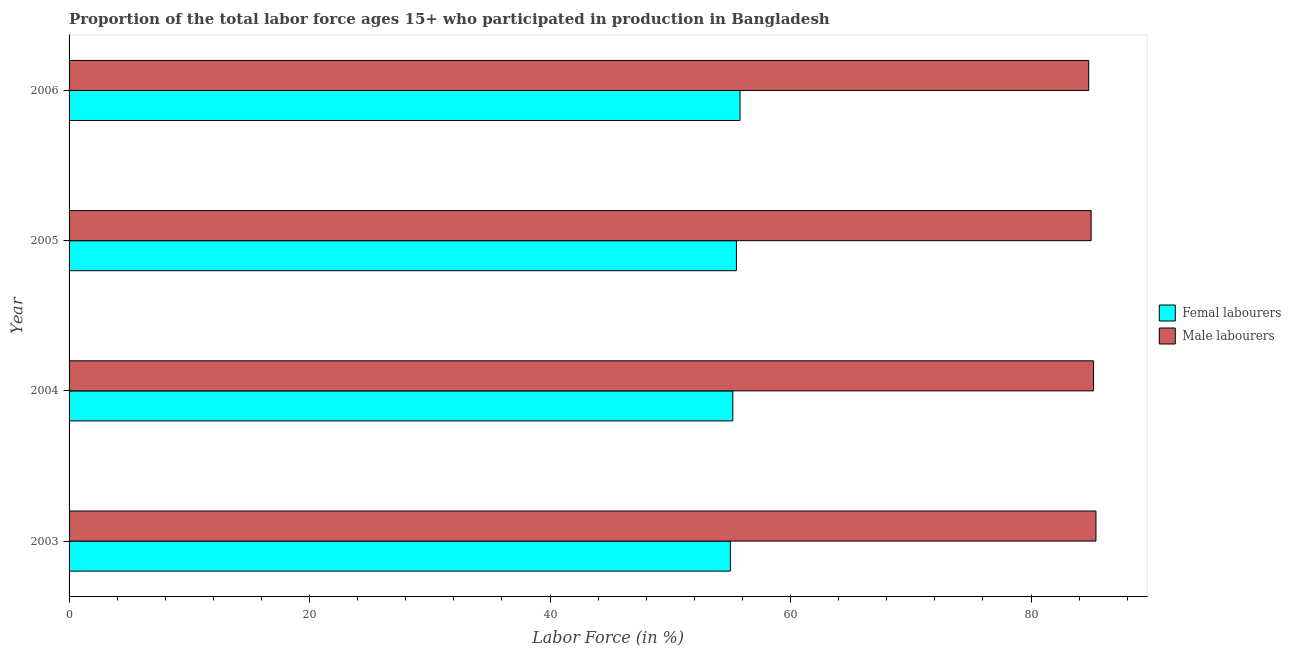Are the number of bars per tick equal to the number of legend labels?
Ensure brevity in your answer.  Yes. Are the number of bars on each tick of the Y-axis equal?
Your response must be concise. Yes. How many bars are there on the 2nd tick from the top?
Your response must be concise. 2. How many bars are there on the 4th tick from the bottom?
Offer a very short reply. 2. What is the label of the 3rd group of bars from the top?
Make the answer very short. 2004. In how many cases, is the number of bars for a given year not equal to the number of legend labels?
Offer a terse response. 0. What is the percentage of male labour force in 2004?
Offer a very short reply. 85.2. Across all years, what is the maximum percentage of female labor force?
Make the answer very short. 55.8. Across all years, what is the minimum percentage of female labor force?
Your answer should be very brief. 55. In which year was the percentage of male labour force minimum?
Provide a short and direct response. 2006. What is the total percentage of female labor force in the graph?
Offer a terse response. 221.5. What is the difference between the percentage of female labor force in 2003 and that in 2005?
Offer a terse response. -0.5. What is the difference between the percentage of female labor force in 2004 and the percentage of male labour force in 2003?
Your answer should be very brief. -30.2. What is the average percentage of male labour force per year?
Give a very brief answer. 85.1. In the year 2004, what is the difference between the percentage of male labour force and percentage of female labor force?
Keep it short and to the point. 30. Is the difference between the percentage of female labor force in 2003 and 2004 greater than the difference between the percentage of male labour force in 2003 and 2004?
Provide a short and direct response. No. What is the difference between the highest and the second highest percentage of female labor force?
Your answer should be very brief. 0.3. What is the difference between the highest and the lowest percentage of male labour force?
Your answer should be very brief. 0.6. What does the 2nd bar from the top in 2004 represents?
Your answer should be compact. Femal labourers. What does the 2nd bar from the bottom in 2003 represents?
Make the answer very short. Male labourers. How many bars are there?
Provide a succinct answer. 8. How many years are there in the graph?
Your response must be concise. 4. Are the values on the major ticks of X-axis written in scientific E-notation?
Ensure brevity in your answer.  No. Does the graph contain any zero values?
Your answer should be very brief. No. Where does the legend appear in the graph?
Ensure brevity in your answer.  Center right. What is the title of the graph?
Offer a very short reply. Proportion of the total labor force ages 15+ who participated in production in Bangladesh. What is the label or title of the X-axis?
Offer a very short reply. Labor Force (in %). What is the Labor Force (in %) in Male labourers in 2003?
Your answer should be very brief. 85.4. What is the Labor Force (in %) of Femal labourers in 2004?
Keep it short and to the point. 55.2. What is the Labor Force (in %) of Male labourers in 2004?
Ensure brevity in your answer.  85.2. What is the Labor Force (in %) of Femal labourers in 2005?
Provide a succinct answer. 55.5. What is the Labor Force (in %) in Male labourers in 2005?
Offer a terse response. 85. What is the Labor Force (in %) of Femal labourers in 2006?
Your answer should be compact. 55.8. What is the Labor Force (in %) of Male labourers in 2006?
Ensure brevity in your answer.  84.8. Across all years, what is the maximum Labor Force (in %) of Femal labourers?
Your response must be concise. 55.8. Across all years, what is the maximum Labor Force (in %) of Male labourers?
Provide a succinct answer. 85.4. Across all years, what is the minimum Labor Force (in %) in Male labourers?
Offer a terse response. 84.8. What is the total Labor Force (in %) in Femal labourers in the graph?
Ensure brevity in your answer.  221.5. What is the total Labor Force (in %) of Male labourers in the graph?
Keep it short and to the point. 340.4. What is the difference between the Labor Force (in %) in Femal labourers in 2003 and that in 2004?
Offer a terse response. -0.2. What is the difference between the Labor Force (in %) in Male labourers in 2003 and that in 2006?
Keep it short and to the point. 0.6. What is the difference between the Labor Force (in %) of Femal labourers in 2004 and that in 2005?
Offer a very short reply. -0.3. What is the difference between the Labor Force (in %) in Femal labourers in 2004 and that in 2006?
Provide a succinct answer. -0.6. What is the difference between the Labor Force (in %) in Male labourers in 2004 and that in 2006?
Make the answer very short. 0.4. What is the difference between the Labor Force (in %) in Femal labourers in 2005 and that in 2006?
Offer a very short reply. -0.3. What is the difference between the Labor Force (in %) in Male labourers in 2005 and that in 2006?
Make the answer very short. 0.2. What is the difference between the Labor Force (in %) of Femal labourers in 2003 and the Labor Force (in %) of Male labourers in 2004?
Provide a succinct answer. -30.2. What is the difference between the Labor Force (in %) of Femal labourers in 2003 and the Labor Force (in %) of Male labourers in 2005?
Provide a short and direct response. -30. What is the difference between the Labor Force (in %) of Femal labourers in 2003 and the Labor Force (in %) of Male labourers in 2006?
Your answer should be compact. -29.8. What is the difference between the Labor Force (in %) of Femal labourers in 2004 and the Labor Force (in %) of Male labourers in 2005?
Make the answer very short. -29.8. What is the difference between the Labor Force (in %) in Femal labourers in 2004 and the Labor Force (in %) in Male labourers in 2006?
Your response must be concise. -29.6. What is the difference between the Labor Force (in %) in Femal labourers in 2005 and the Labor Force (in %) in Male labourers in 2006?
Your response must be concise. -29.3. What is the average Labor Force (in %) in Femal labourers per year?
Your answer should be compact. 55.38. What is the average Labor Force (in %) in Male labourers per year?
Offer a terse response. 85.1. In the year 2003, what is the difference between the Labor Force (in %) in Femal labourers and Labor Force (in %) in Male labourers?
Give a very brief answer. -30.4. In the year 2005, what is the difference between the Labor Force (in %) in Femal labourers and Labor Force (in %) in Male labourers?
Your response must be concise. -29.5. In the year 2006, what is the difference between the Labor Force (in %) of Femal labourers and Labor Force (in %) of Male labourers?
Your response must be concise. -29. What is the ratio of the Labor Force (in %) of Male labourers in 2003 to that in 2004?
Provide a short and direct response. 1. What is the ratio of the Labor Force (in %) in Male labourers in 2003 to that in 2005?
Your answer should be very brief. 1. What is the ratio of the Labor Force (in %) in Femal labourers in 2003 to that in 2006?
Offer a very short reply. 0.99. What is the ratio of the Labor Force (in %) of Male labourers in 2003 to that in 2006?
Provide a succinct answer. 1.01. What is the ratio of the Labor Force (in %) in Femal labourers in 2004 to that in 2006?
Your answer should be very brief. 0.99. What is the ratio of the Labor Force (in %) in Male labourers in 2004 to that in 2006?
Give a very brief answer. 1. What is the ratio of the Labor Force (in %) of Male labourers in 2005 to that in 2006?
Make the answer very short. 1. What is the difference between the highest and the second highest Labor Force (in %) in Femal labourers?
Provide a succinct answer. 0.3. What is the difference between the highest and the second highest Labor Force (in %) in Male labourers?
Make the answer very short. 0.2. 